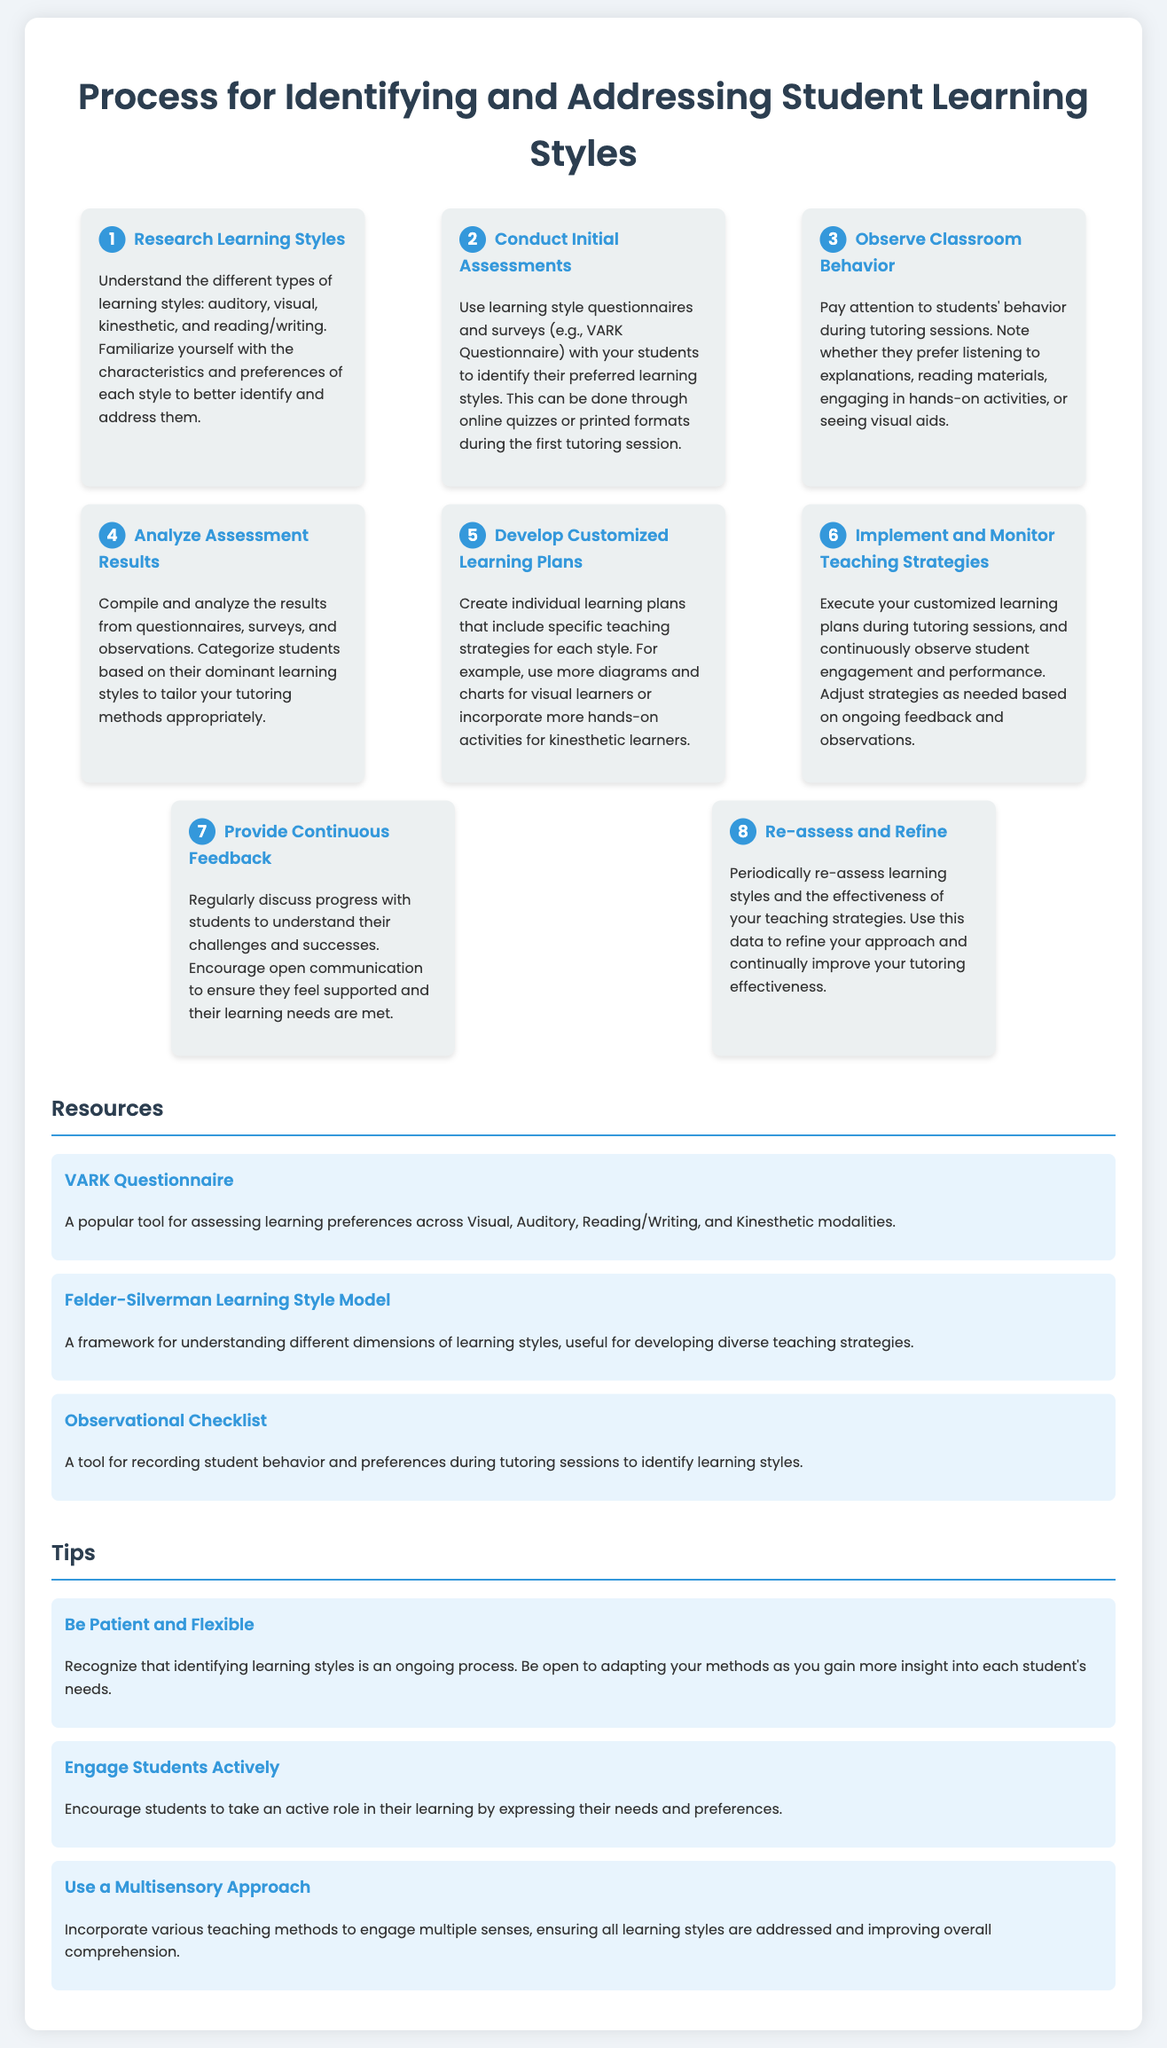What is the first step in the process? The first step involves researching different types of learning styles to better identify and address them.
Answer: Research Learning Styles What questionnaire is recommended for assessing learning styles? The document suggests using the VARK Questionnaire as a tool for assessing learning preferences.
Answer: VARK Questionnaire How many steps are there in the process? The infographic outlines a total of eight steps in the process for identifying and addressing student learning styles.
Answer: 8 What is recommended to create after analyzing assessment results? After analyzing results, the next step is to develop customized learning plans tailored to each student's learning style.
Answer: Develop Customized Learning Plans What should be regularly discussed with students? Tutors should regularly discuss progress with students to understand their challenges and successes.
Answer: Progress What is a tip for engaging students actively? One tip for engaging students is to encourage them to express their needs and preferences in their learning.
Answer: Engage Students Actively What type of approach should be incorporated for teaching? The document recommends using a multisensory approach to engage multiple senses and address all learning styles.
Answer: Multisensory Approach What is suggested for monitoring teaching strategies? The document advises to continuously observe student engagement and performance to adjust strategies as needed.
Answer: Monitor Teaching Strategies 